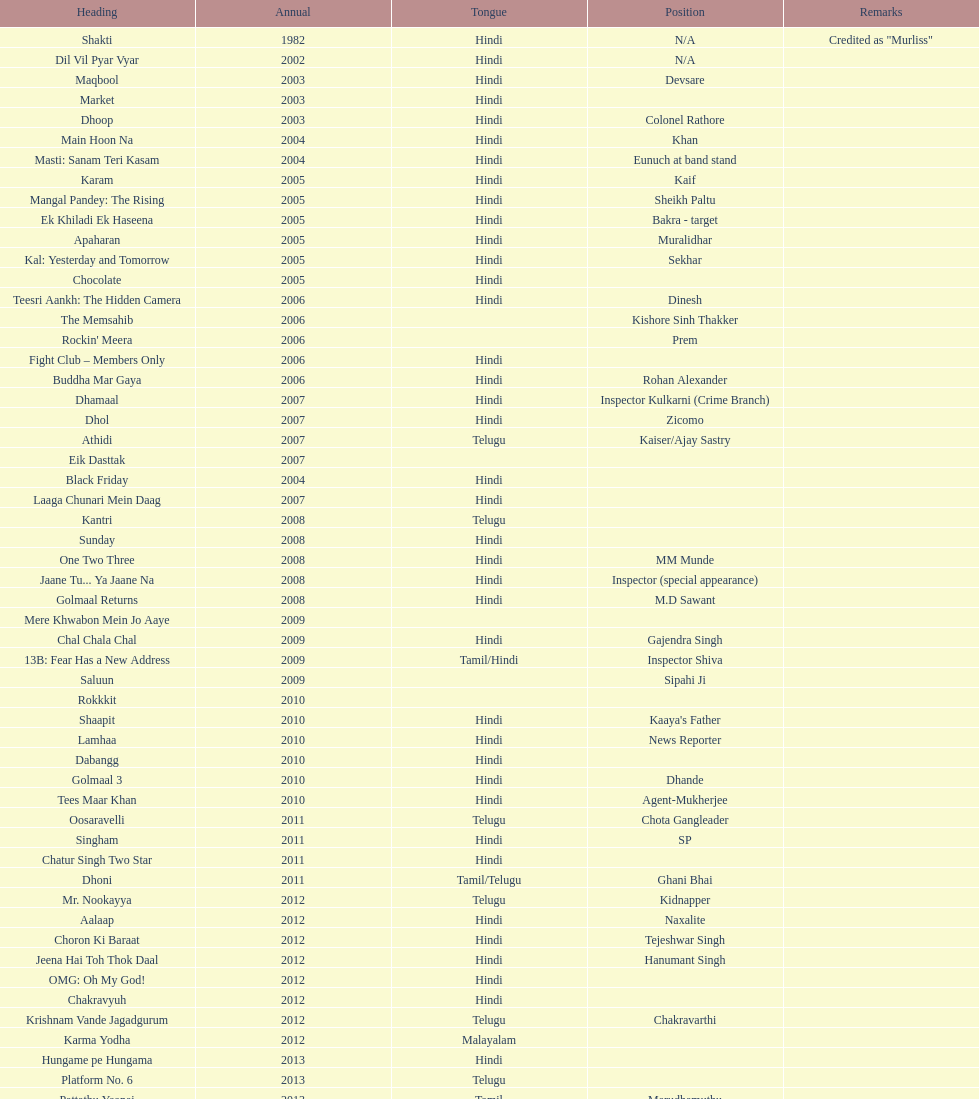How many parts has this actor played? 36. 